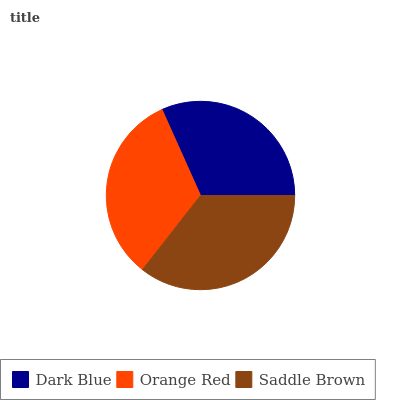Is Dark Blue the minimum?
Answer yes or no. Yes. Is Saddle Brown the maximum?
Answer yes or no. Yes. Is Orange Red the minimum?
Answer yes or no. No. Is Orange Red the maximum?
Answer yes or no. No. Is Orange Red greater than Dark Blue?
Answer yes or no. Yes. Is Dark Blue less than Orange Red?
Answer yes or no. Yes. Is Dark Blue greater than Orange Red?
Answer yes or no. No. Is Orange Red less than Dark Blue?
Answer yes or no. No. Is Orange Red the high median?
Answer yes or no. Yes. Is Orange Red the low median?
Answer yes or no. Yes. Is Saddle Brown the high median?
Answer yes or no. No. Is Saddle Brown the low median?
Answer yes or no. No. 